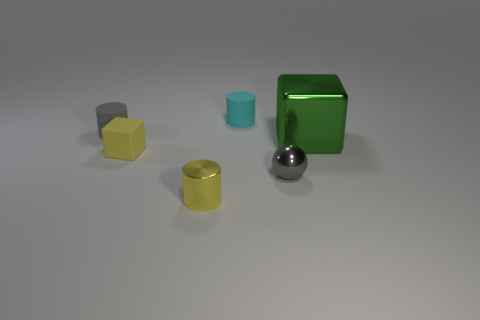Add 2 blue metal cylinders. How many objects exist? 8 Subtract all balls. How many objects are left? 5 Subtract all tiny blue balls. Subtract all gray things. How many objects are left? 4 Add 3 gray rubber cylinders. How many gray rubber cylinders are left? 4 Add 3 large green blocks. How many large green blocks exist? 4 Subtract 0 blue balls. How many objects are left? 6 